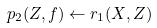<formula> <loc_0><loc_0><loc_500><loc_500>p _ { 2 } ( Z , f ) \leftarrow r _ { 1 } ( X , Z )</formula> 